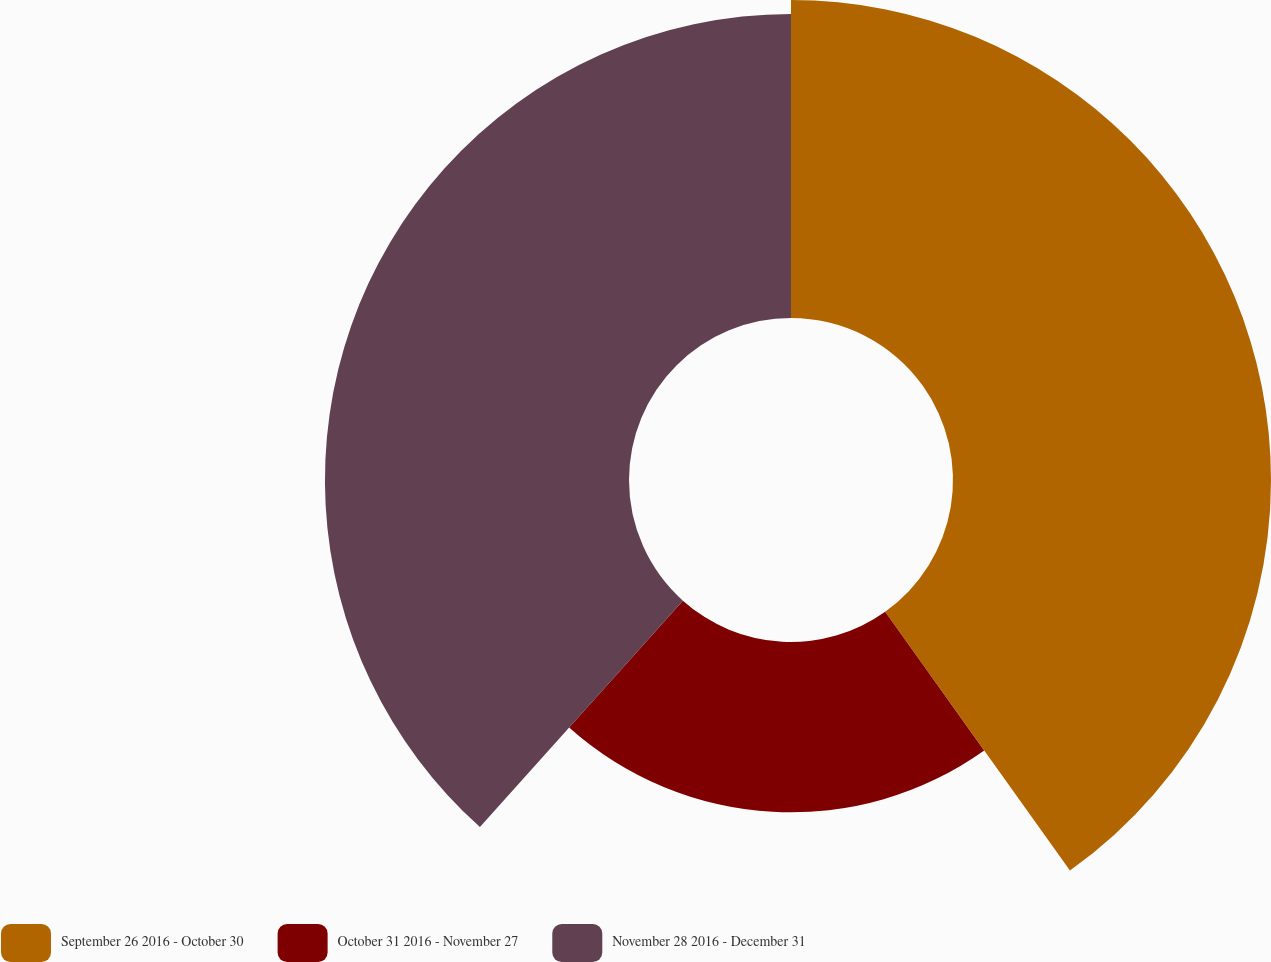Convert chart. <chart><loc_0><loc_0><loc_500><loc_500><pie_chart><fcel>September 26 2016 - October 30<fcel>October 31 2016 - November 27<fcel>November 28 2016 - December 31<nl><fcel>40.13%<fcel>21.5%<fcel>38.37%<nl></chart> 